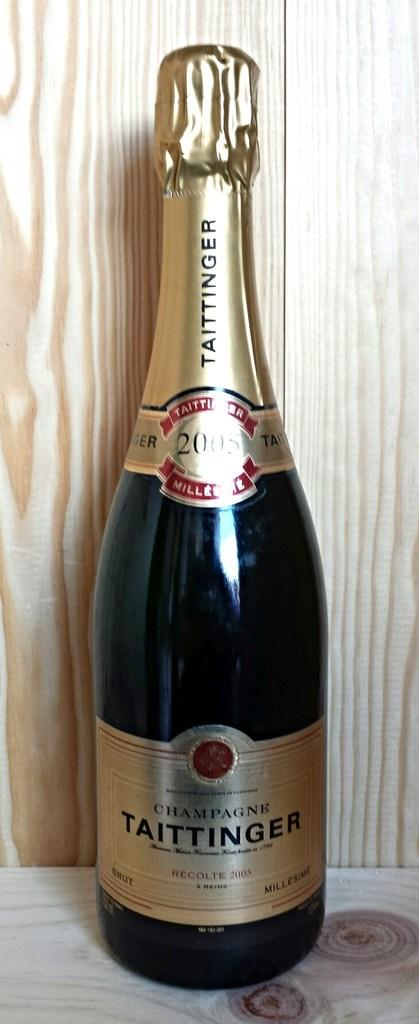<image>
Summarize the visual content of the image. a bottle of taittinger champagne recolte in 2005 